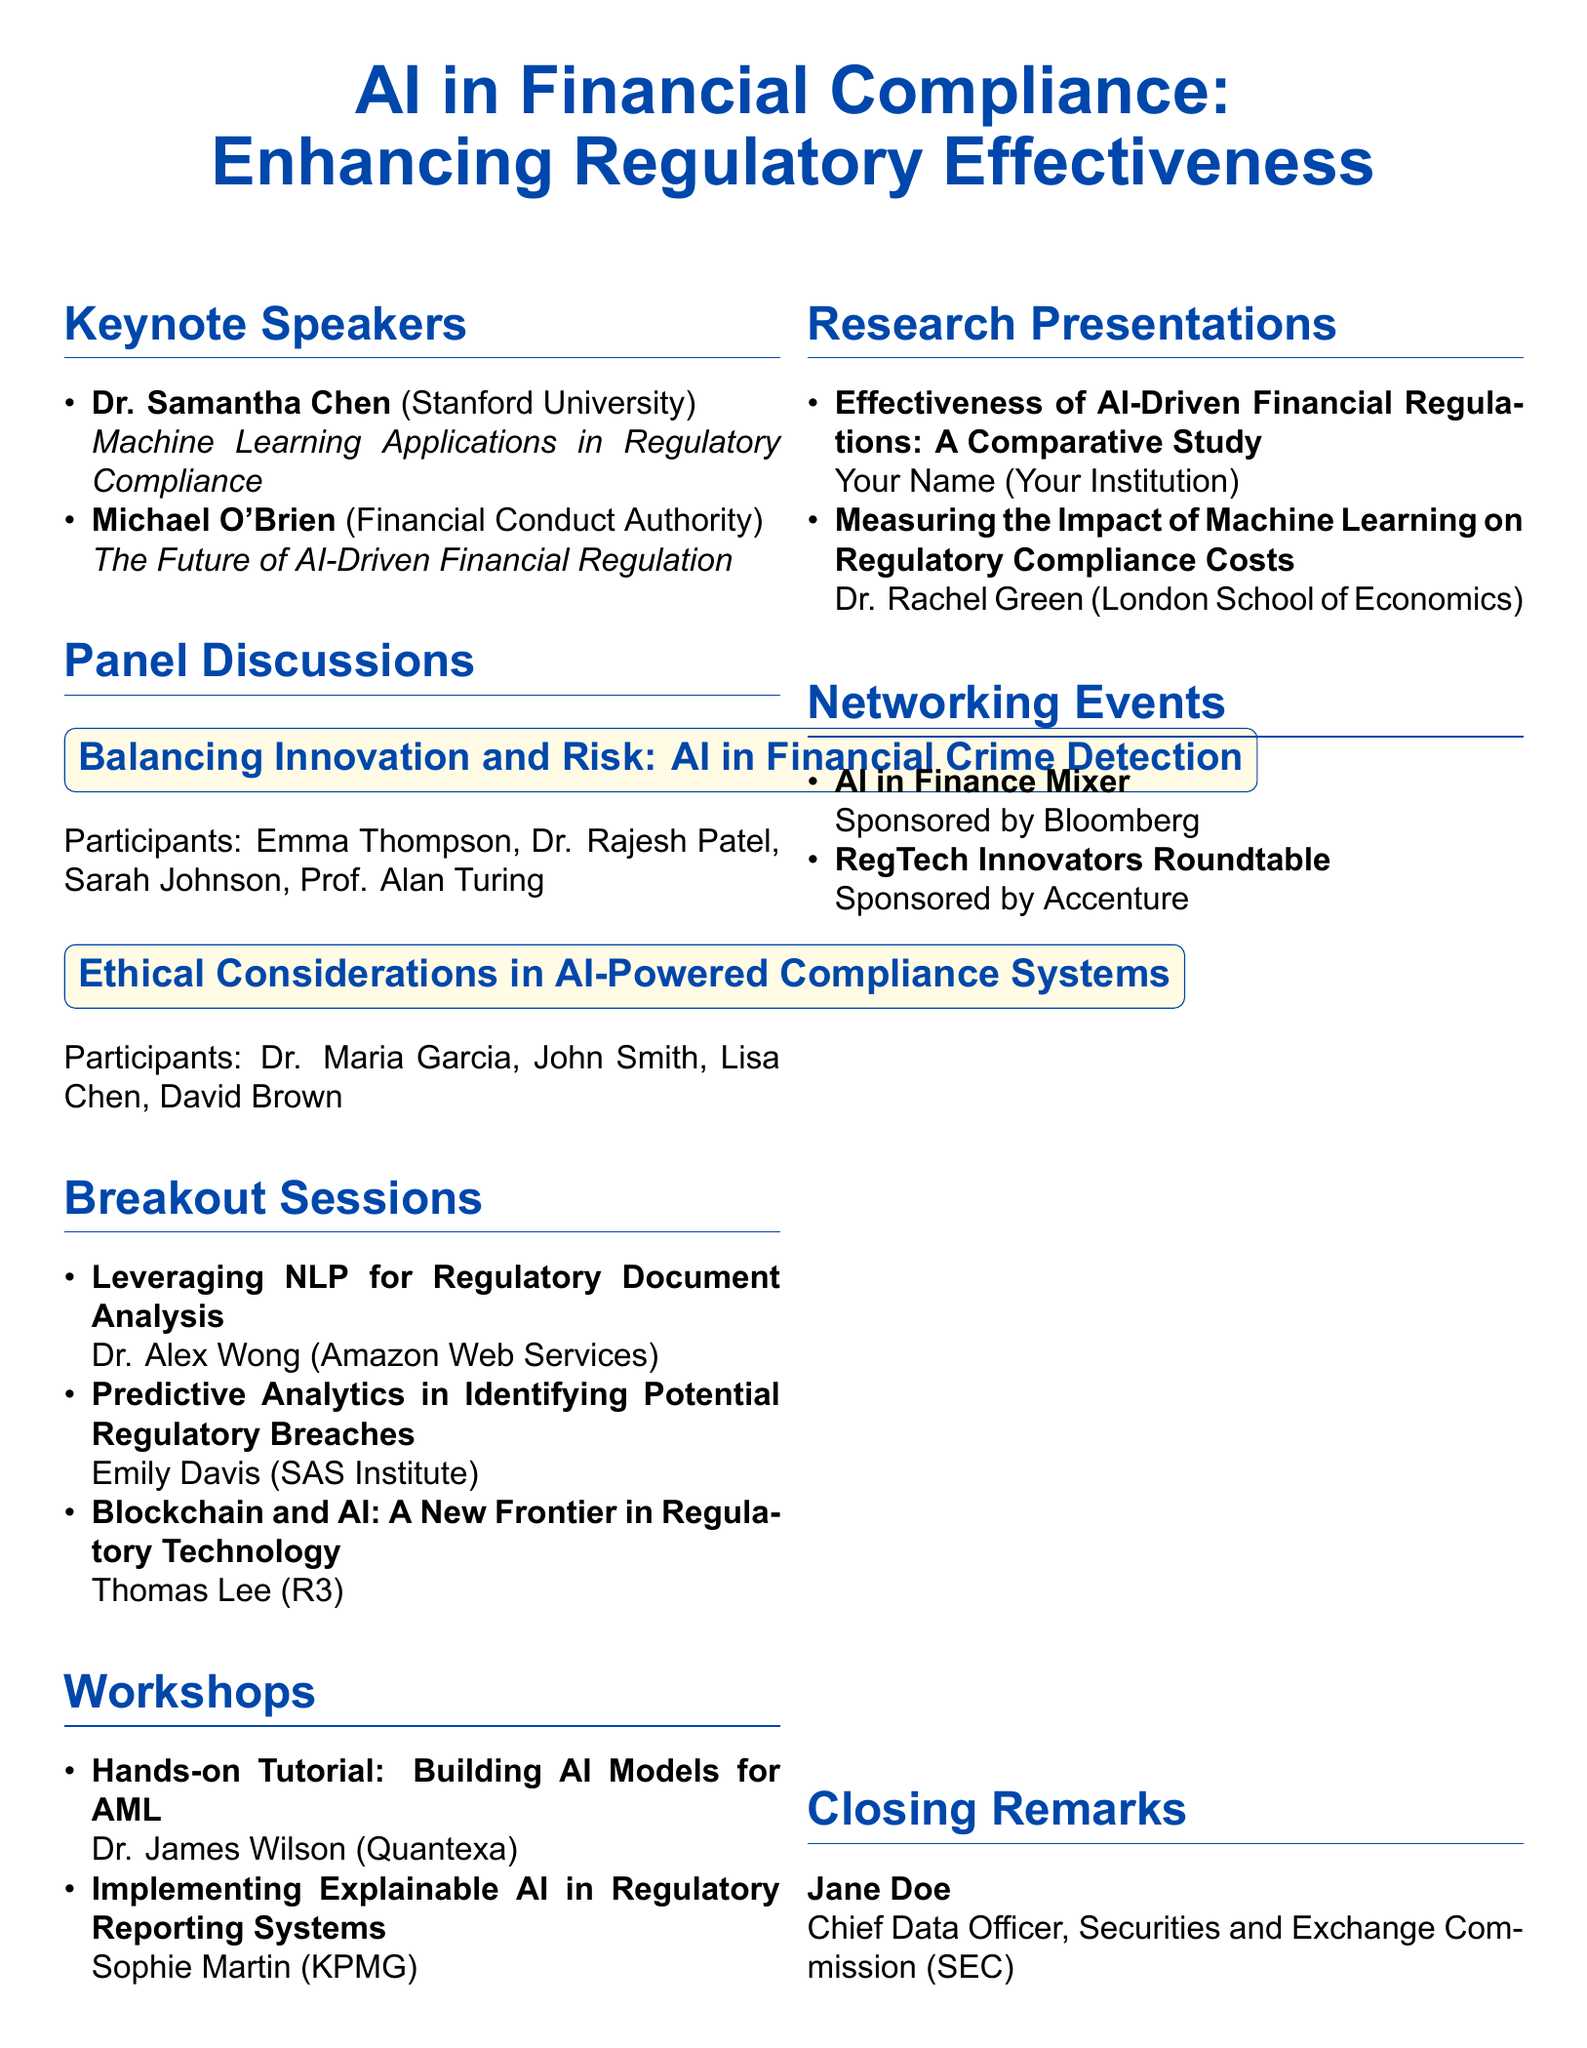What is the title of the conference? The title of the conference is mentioned at the beginning of the document.
Answer: AI in Financial Compliance: Enhancing Regulatory Effectiveness Who is the keynote speaker from Stanford University? The document lists the keynote speakers with their affiliations and topics.
Answer: Dr. Samantha Chen What is the focus of the panel discussion titled "Ethical Considerations in AI-Powered Compliance Systems"? The document specifies the titles of the panel discussions.
Answer: Ethical Considerations in AI-Powered Compliance Systems How many breakout sessions are listed in the agenda? The document enumerates the breakout sessions provided, along with their titles.
Answer: 3 Who is presenting the research on the effectiveness of AI-driven financial regulations? The document assigns presenters to the research presentations, specifically naming the presenter for that title.
Answer: Your Name What is the title of the workshop conducted by Sophie Martin? The document includes the titles of all workshops and their instructors.
Answer: Implementing Explainable AI in Regulatory Reporting Systems Which company sponsors the "AI in Finance Mixer"? The document indicates the sponsors for networking events, detailing the specific event sponsors.
Answer: Bloomberg In which city is the conference likely held based on the affiliation of keynote speaker Michael O'Brien? Michael O'Brien is affiliated with the Financial Conduct Authority, which is based in London, UK.
Answer: London 